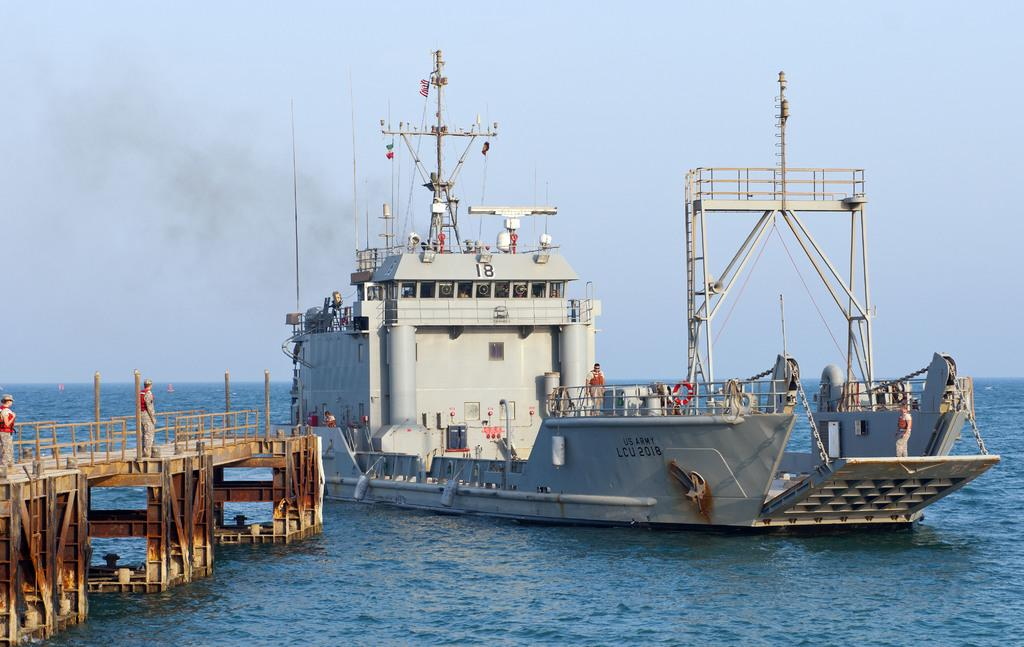What is the main subject of the image? The main subject of the image is a ship on the water. What other structures or objects can be seen in the image? There is a bridge in the image. Are there any living beings visible in the image? Yes, there are people visible in the image. What can be seen in the background of the image? The sky is visible in the background of the image. Where is the nest of the insect located in the image? There is no nest or insect present in the image. What type of industry can be seen in the background of the image? There is no industry visible in the image; it primarily features a ship, a bridge, people, and the sky. 